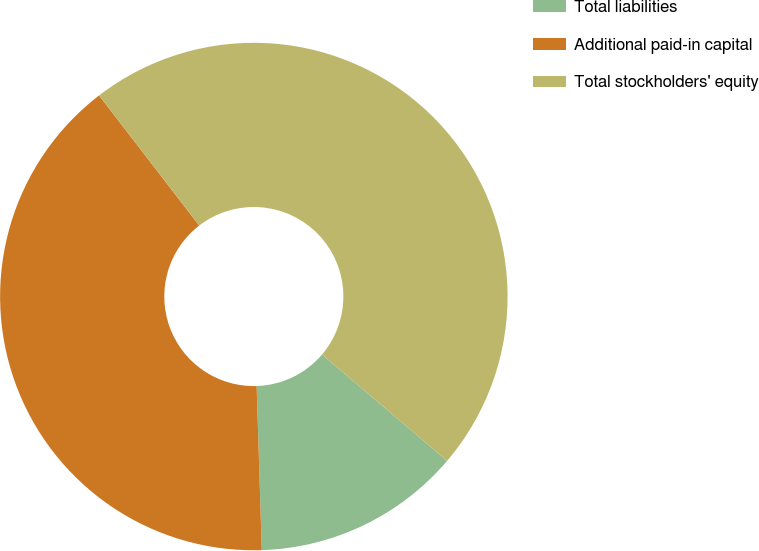<chart> <loc_0><loc_0><loc_500><loc_500><pie_chart><fcel>Total liabilities<fcel>Additional paid-in capital<fcel>Total stockholders' equity<nl><fcel>13.29%<fcel>40.06%<fcel>46.65%<nl></chart> 